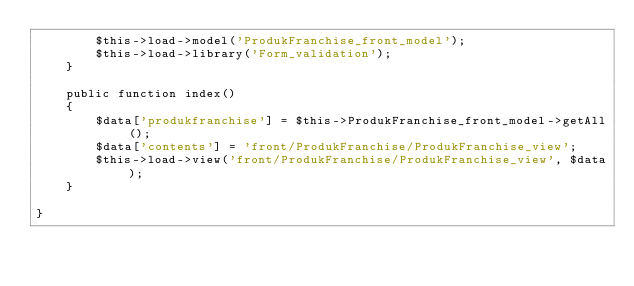<code> <loc_0><loc_0><loc_500><loc_500><_PHP_>        $this->load->model('ProdukFranchise_front_model');
        $this->load->library('Form_validation');
    }
    
    public function index()
    {
        $data['produkfranchise'] = $this->ProdukFranchise_front_model->getAll();
        $data['contents'] = 'front/ProdukFranchise/ProdukFranchise_view';
        $this->load->view('front/ProdukFranchise/ProdukFranchise_view', $data);
    }

}
</code> 